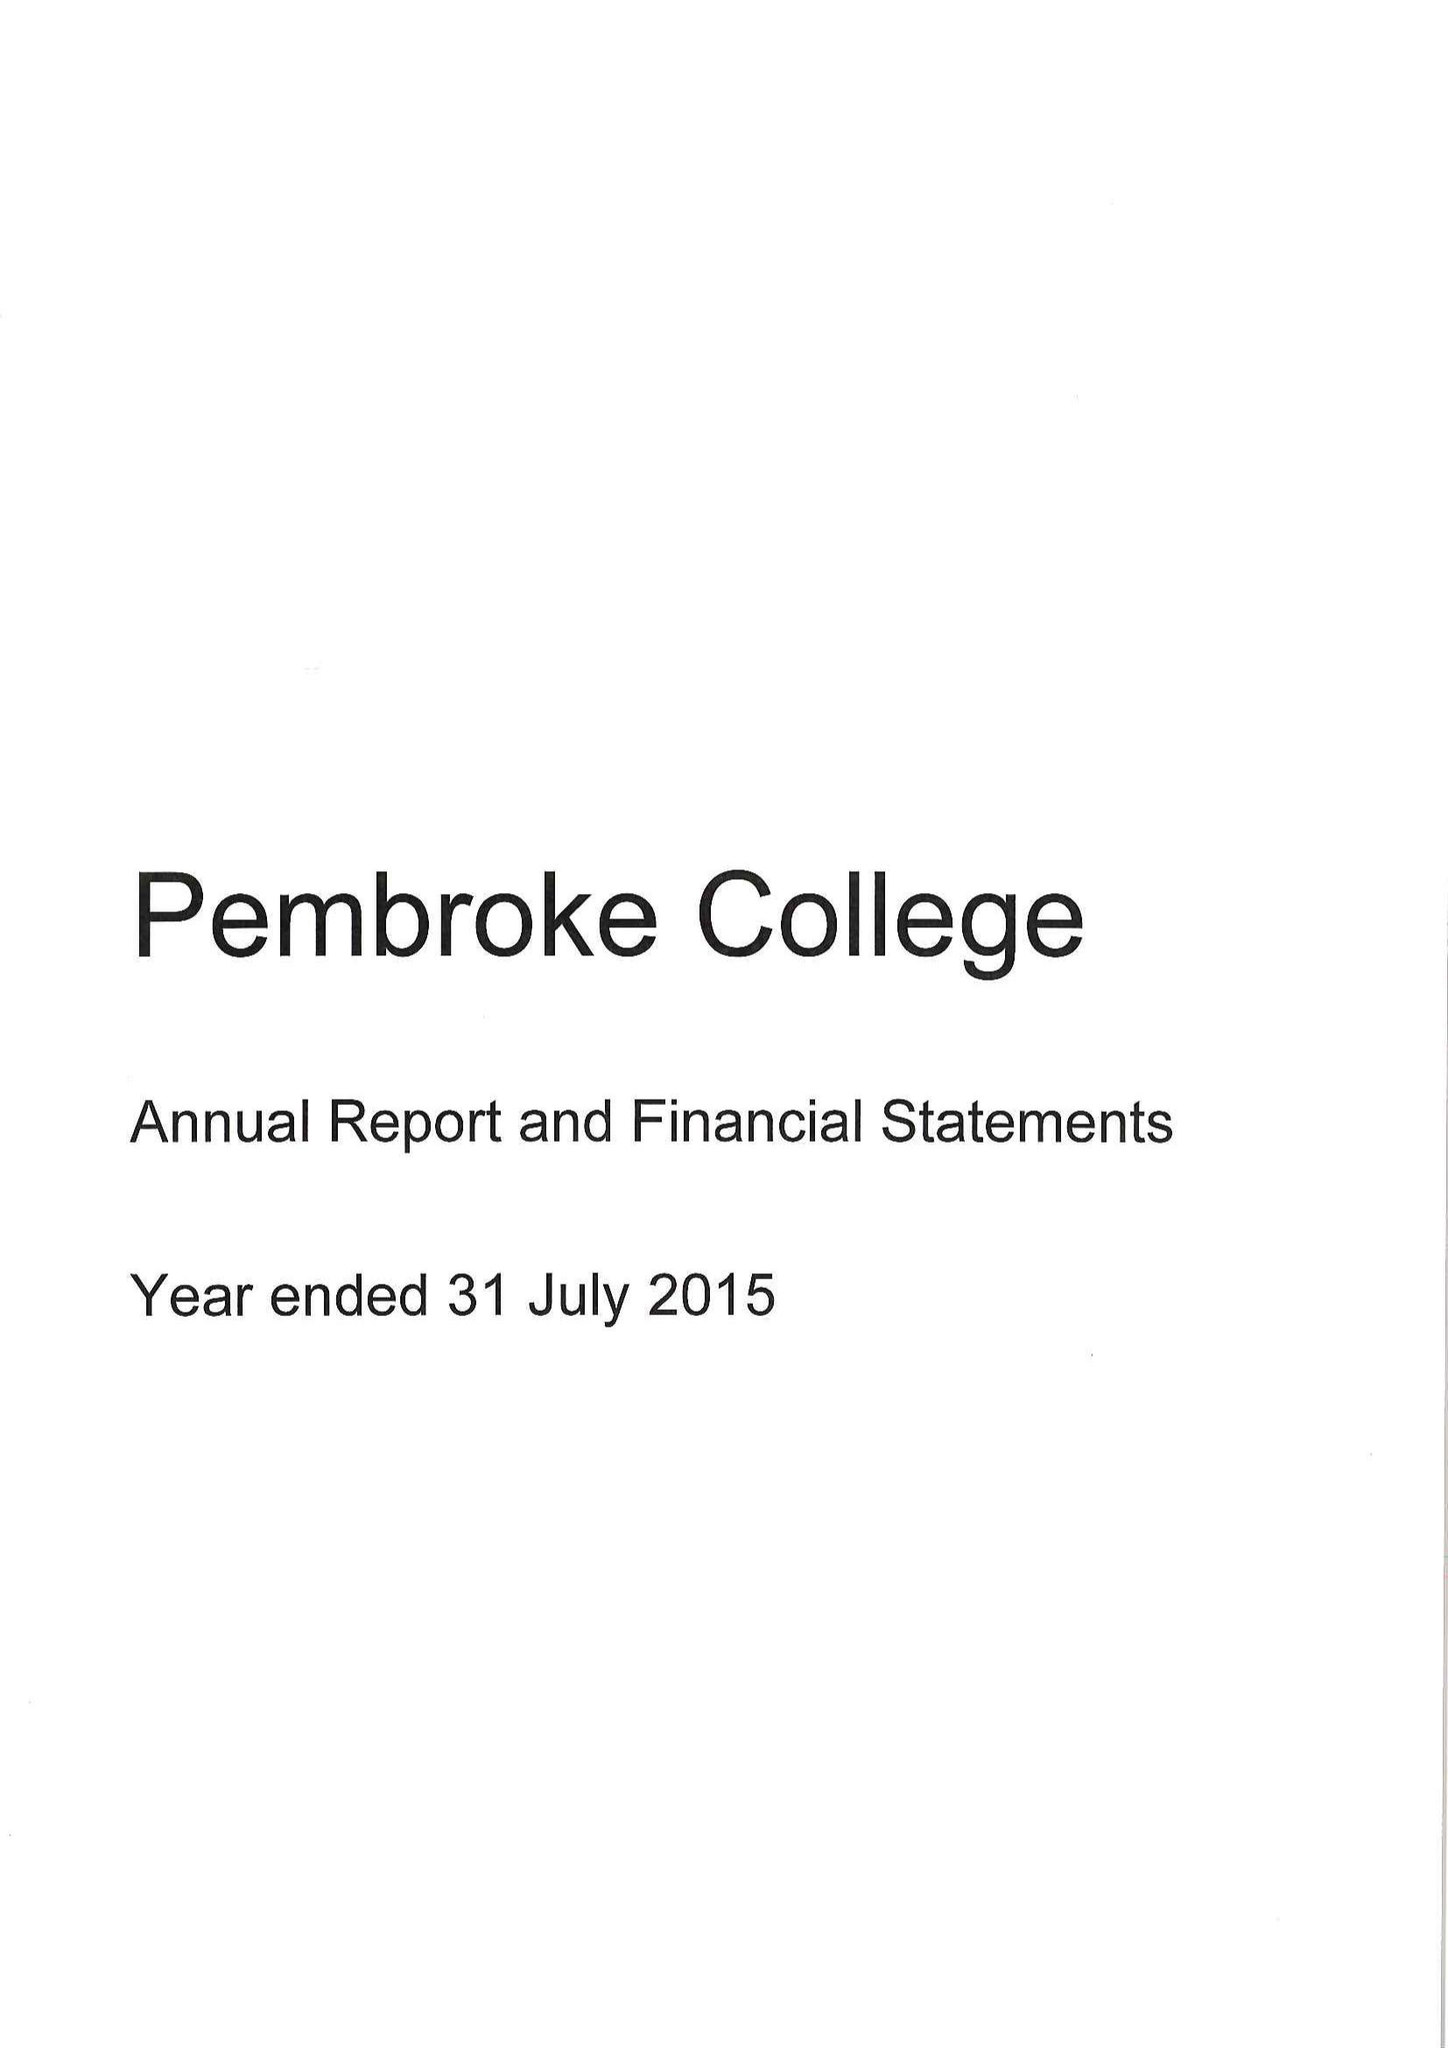What is the value for the address__street_line?
Answer the question using a single word or phrase. ST ALDATES 